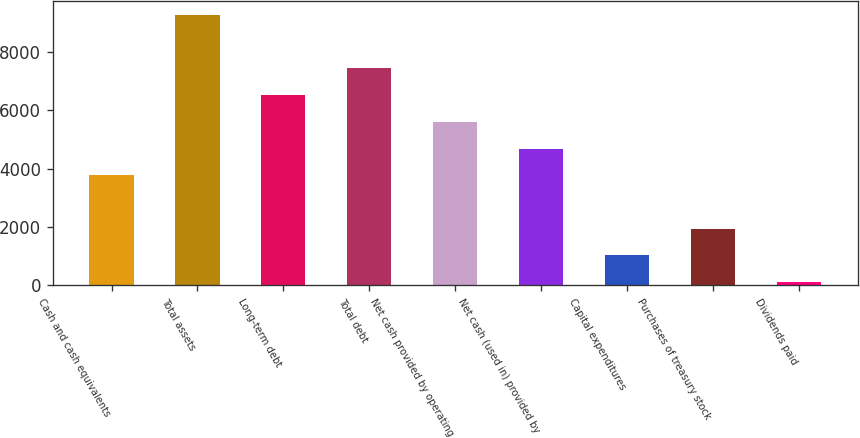<chart> <loc_0><loc_0><loc_500><loc_500><bar_chart><fcel>Cash and cash equivalents<fcel>Total assets<fcel>Long-term debt<fcel>Total debt<fcel>Net cash provided by operating<fcel>Net cash (used in) provided by<fcel>Capital expenditures<fcel>Purchases of treasury stock<fcel>Dividends paid<nl><fcel>3770<fcel>9263<fcel>6516.5<fcel>7432<fcel>5601<fcel>4685.5<fcel>1023.5<fcel>1939<fcel>108<nl></chart> 